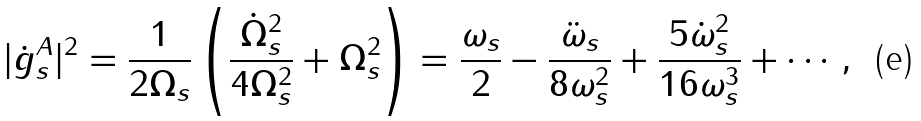Convert formula to latex. <formula><loc_0><loc_0><loc_500><loc_500>| \dot { g } _ { s } ^ { A } | ^ { 2 } = \frac { 1 } { 2 \Omega _ { s } } \left ( \frac { \dot { \Omega } _ { s } ^ { 2 } } { 4 \Omega _ { s } ^ { 2 } } + \Omega _ { s } ^ { 2 } \right ) = \frac { \omega _ { s } } { 2 } - \frac { \ddot { \omega } _ { s } } { 8 \omega _ { s } ^ { 2 } } + \frac { 5 \dot { \omega } _ { s } ^ { 2 } } { 1 6 \omega _ { s } ^ { 3 } } + \cdots ,</formula> 